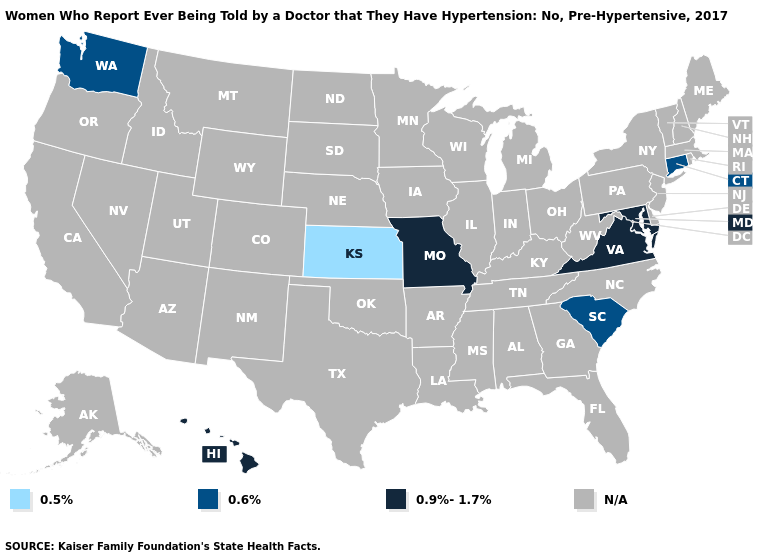Name the states that have a value in the range 0.9%-1.7%?
Short answer required. Hawaii, Maryland, Missouri, Virginia. What is the value of Ohio?
Give a very brief answer. N/A. Is the legend a continuous bar?
Write a very short answer. No. Name the states that have a value in the range 0.9%-1.7%?
Short answer required. Hawaii, Maryland, Missouri, Virginia. Which states have the lowest value in the USA?
Give a very brief answer. Kansas. What is the value of Washington?
Be succinct. 0.6%. Which states have the lowest value in the USA?
Short answer required. Kansas. Name the states that have a value in the range 0.6%?
Give a very brief answer. Connecticut, South Carolina, Washington. Name the states that have a value in the range 0.5%?
Write a very short answer. Kansas. What is the value of South Carolina?
Concise answer only. 0.6%. Is the legend a continuous bar?
Concise answer only. No. 